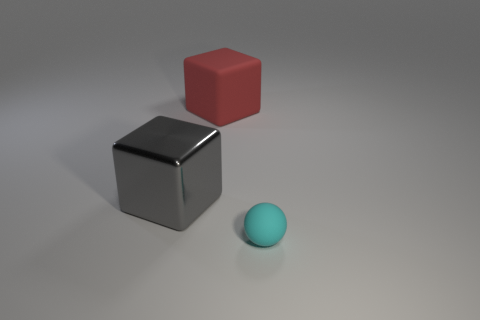Add 1 tiny cyan matte blocks. How many objects exist? 4 Subtract all spheres. How many objects are left? 2 Subtract all purple spheres. Subtract all balls. How many objects are left? 2 Add 2 big red blocks. How many big red blocks are left? 3 Add 2 tiny brown rubber blocks. How many tiny brown rubber blocks exist? 2 Subtract 0 cyan cylinders. How many objects are left? 3 